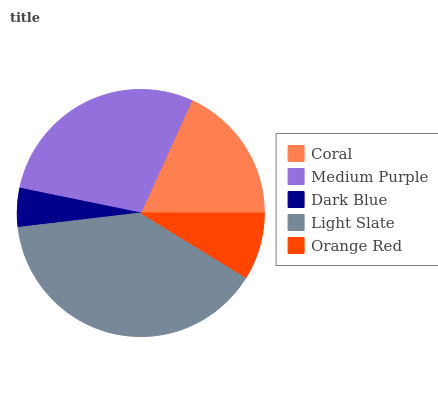Is Dark Blue the minimum?
Answer yes or no. Yes. Is Light Slate the maximum?
Answer yes or no. Yes. Is Medium Purple the minimum?
Answer yes or no. No. Is Medium Purple the maximum?
Answer yes or no. No. Is Medium Purple greater than Coral?
Answer yes or no. Yes. Is Coral less than Medium Purple?
Answer yes or no. Yes. Is Coral greater than Medium Purple?
Answer yes or no. No. Is Medium Purple less than Coral?
Answer yes or no. No. Is Coral the high median?
Answer yes or no. Yes. Is Coral the low median?
Answer yes or no. Yes. Is Dark Blue the high median?
Answer yes or no. No. Is Dark Blue the low median?
Answer yes or no. No. 